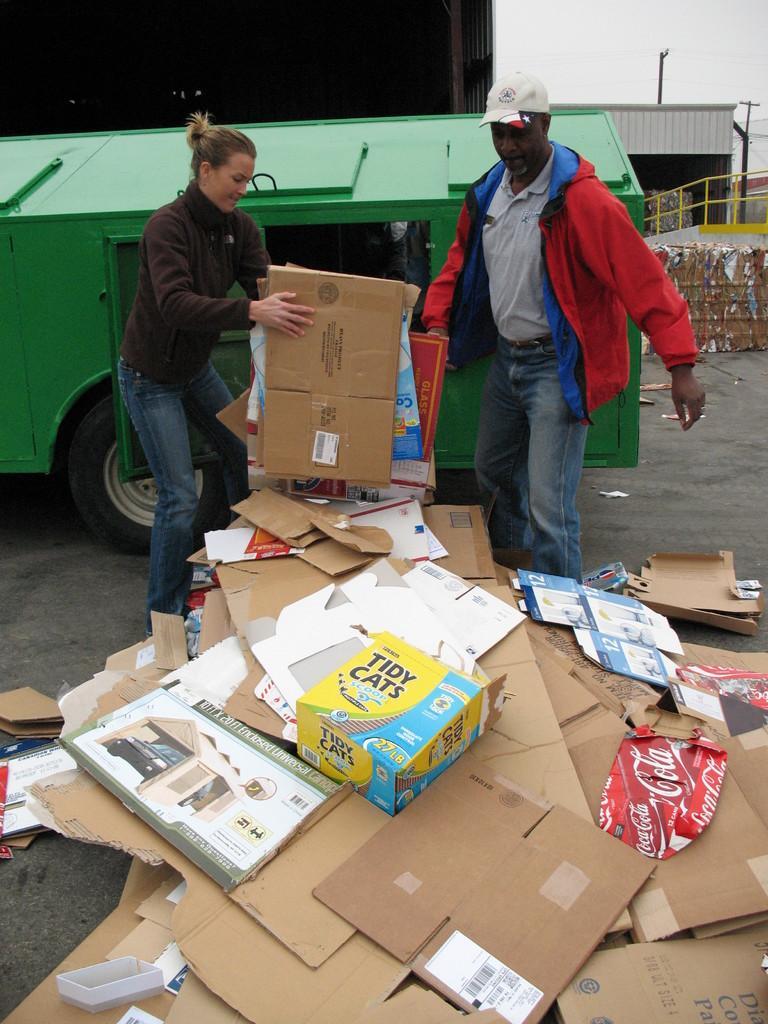In one or two sentences, can you explain what this image depicts? In this image I can see number of carton papers on the ground. I can also see two persons are standing and I can see one of them is holding few carton papers. In the background I can see a green colour vehicle, two buildings, the iron fence, two poles and the sky. I can also see something is written on these papers. 